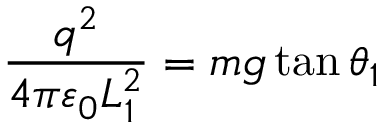<formula> <loc_0><loc_0><loc_500><loc_500>{ \frac { q ^ { 2 } } { 4 \pi \varepsilon _ { 0 } L _ { 1 } ^ { 2 } } } = m g \tan \theta _ { 1 } \,</formula> 